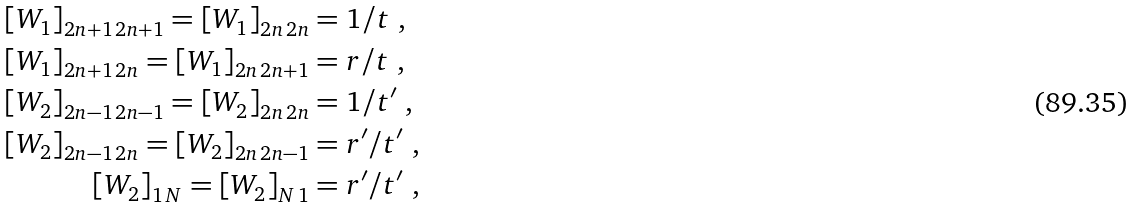Convert formula to latex. <formula><loc_0><loc_0><loc_500><loc_500>\left [ W _ { 1 } \right ] _ { 2 n + 1 \, 2 n + 1 } = \left [ W _ { 1 } \right ] _ { 2 n \, 2 n } & = 1 / t \ , \\ \left [ W _ { 1 } \right ] _ { 2 n + 1 \, 2 n } = \left [ W _ { 1 } \right ] _ { 2 n \, 2 n + 1 } & = r / t \ , \\ \left [ W _ { 2 } \right ] _ { 2 n - 1 \, 2 n - 1 } = \left [ W _ { 2 } \right ] _ { 2 n \, 2 n } & = 1 / t ^ { \prime } \ , \\ \left [ W _ { 2 } \right ] _ { 2 n - 1 \, 2 n } = \left [ W _ { 2 } \right ] _ { 2 n \, 2 n - 1 } & = r ^ { \prime } / t ^ { \prime } \ , \\ \left [ W _ { 2 } \right ] _ { 1 \, N } = \left [ W _ { 2 } \right ] _ { N \, 1 } & = r ^ { \prime } / t ^ { \prime } \ ,</formula> 